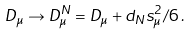<formula> <loc_0><loc_0><loc_500><loc_500>D _ { \mu } \rightarrow D ^ { N } _ { \mu } = D _ { \mu } + d _ { N } s _ { \mu } ^ { 2 } / 6 \, .</formula> 